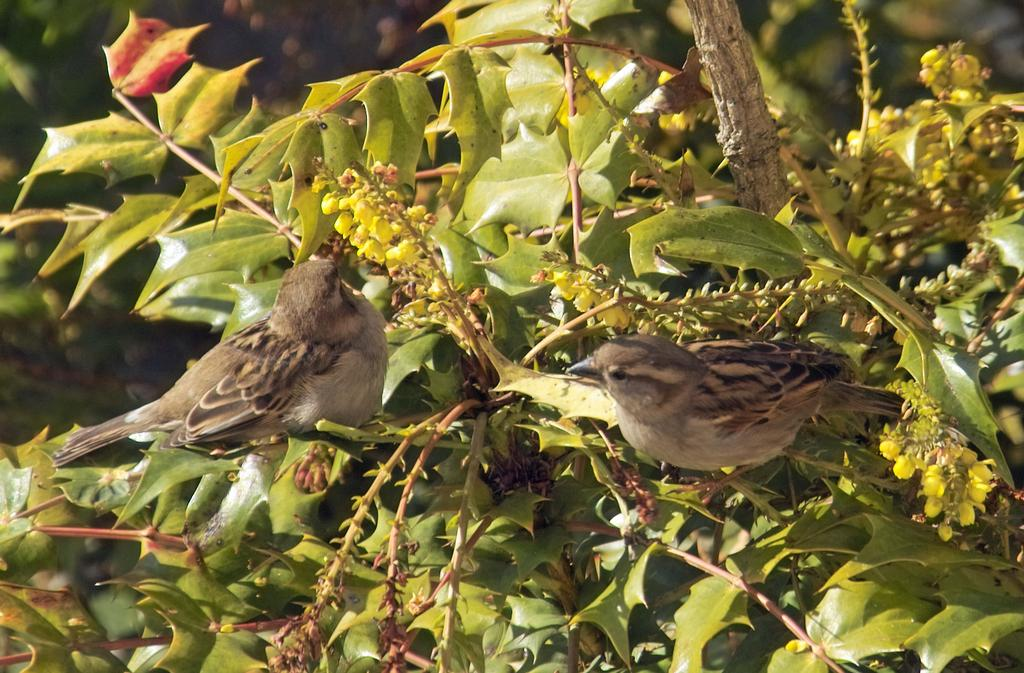What type of animals can be seen in the image? Birds can be seen in the image. What other elements are present in the image besides the birds? There are leaves, stems, a branch, and buds in the image. Can you describe the vegetation in the image? The vegetation includes leaves, stems, a branch, and buds. How is the background of the image depicted? The background of the image is blurry. What language is the bird speaking in the image? Birds do not speak human languages, so it is not possible to determine what language the bird might be speaking in the image. 